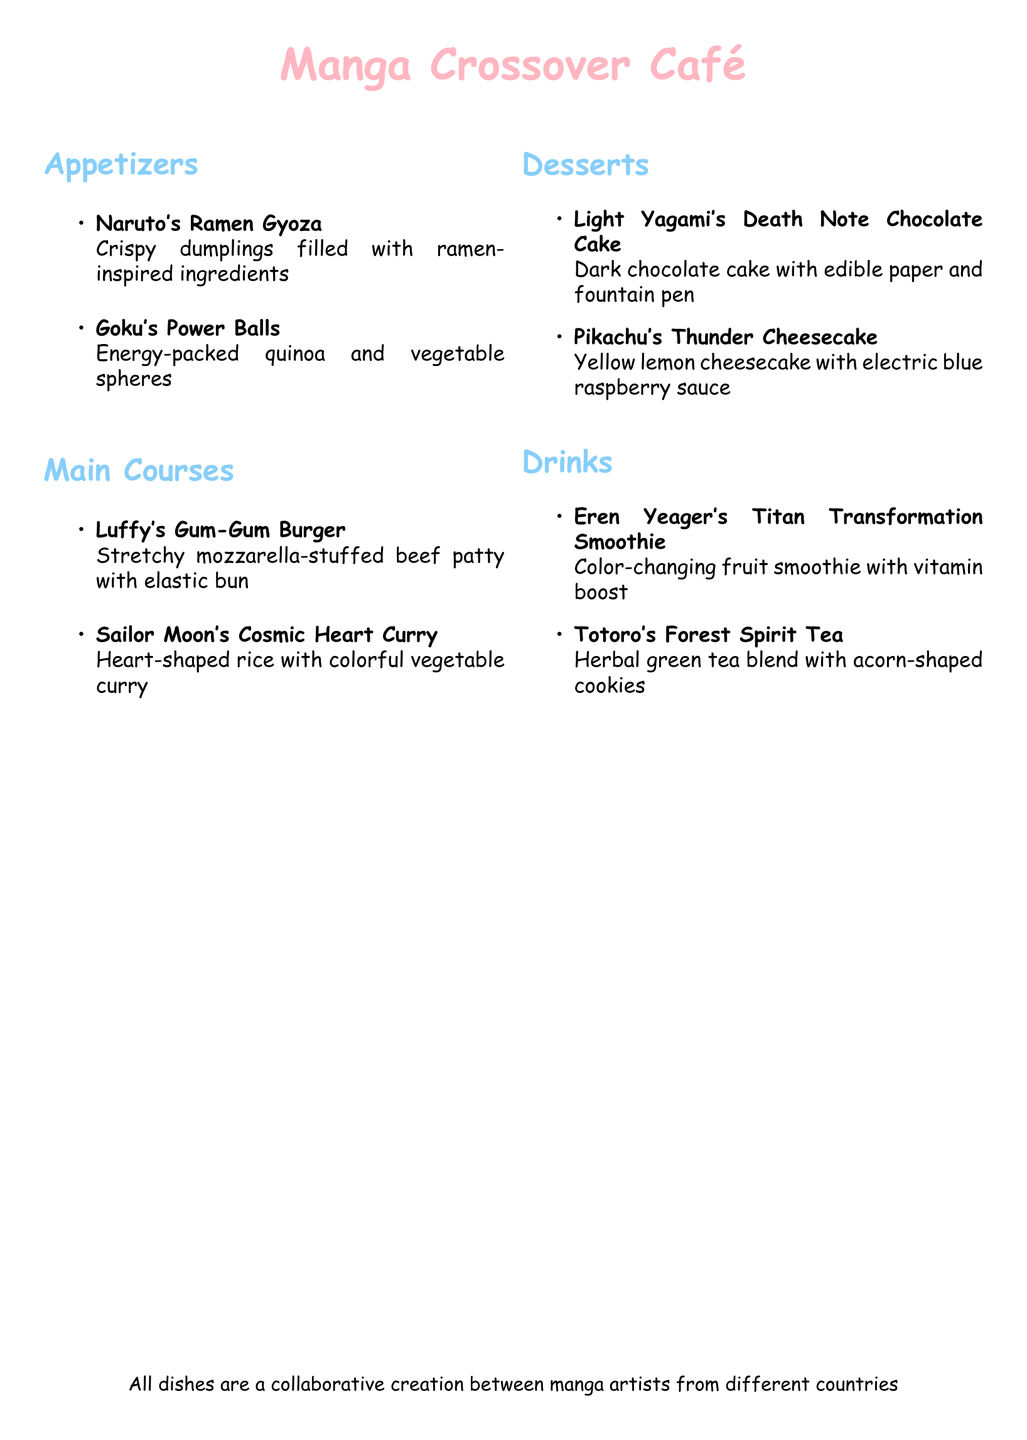What is the name of the dessert inspired by Light Yagami? The dessert inspired by Light Yagami is a chocolate cake mentioned in the "Desserts" section.
Answer: Death Note Chocolate Cake What type of tea is named after Totoro? The tea's name is found in the "Drinks" section, specifically named after a forest spirit character.
Answer: Forest Spirit Tea How many appetizers are listed on the menu? The number of appetizers can be counted directly from the "Appetizers" section of the document.
Answer: 2 What is the primary filling of Naruto's Ramen Gyoza? The filling of the gyoza is based on ramen-inspired ingredients as described in the "Appetizers" section.
Answer: Ramen-inspired ingredients Which dish includes a stretchy characteristic? The "Main Courses" section mentions a dish with a stretchy feature in its name and description.
Answer: Gum-Gum Burger What color is Pikachu's Thunder Cheesecake? The color of the cheesecake is specified in the "Desserts" section and is described as lemon-yellow.
Answer: Yellow What type of smoothie is Eren Yeager's Titan Transformation? The type of beverage is described in the "Drinks" section, focusing on its color-changing nature.
Answer: Smoothie What is the shape of the rice in Sailor Moon's dish? The shape of the rice is highlighted in the description of Sailor Moon's Cosmic Heart Curry, located in the "Main Courses."
Answer: Heart-shaped 